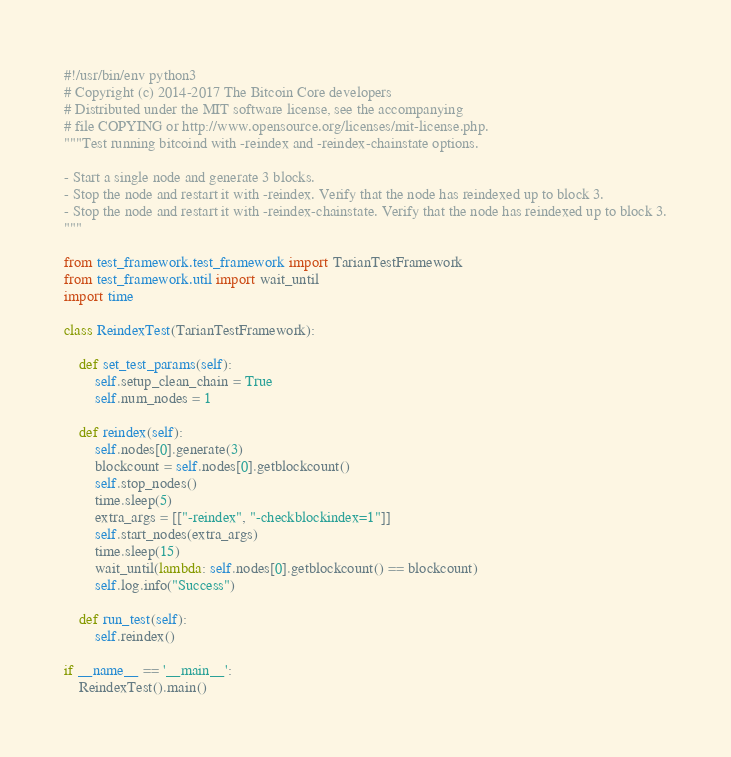Convert code to text. <code><loc_0><loc_0><loc_500><loc_500><_Python_>#!/usr/bin/env python3
# Copyright (c) 2014-2017 The Bitcoin Core developers
# Distributed under the MIT software license, see the accompanying
# file COPYING or http://www.opensource.org/licenses/mit-license.php.
"""Test running bitcoind with -reindex and -reindex-chainstate options.

- Start a single node and generate 3 blocks.
- Stop the node and restart it with -reindex. Verify that the node has reindexed up to block 3.
- Stop the node and restart it with -reindex-chainstate. Verify that the node has reindexed up to block 3.
"""

from test_framework.test_framework import TarianTestFramework
from test_framework.util import wait_until
import time

class ReindexTest(TarianTestFramework):

    def set_test_params(self):
        self.setup_clean_chain = True
        self.num_nodes = 1

    def reindex(self):
        self.nodes[0].generate(3)
        blockcount = self.nodes[0].getblockcount()
        self.stop_nodes()
        time.sleep(5)
        extra_args = [["-reindex", "-checkblockindex=1"]]
        self.start_nodes(extra_args)
        time.sleep(15)
        wait_until(lambda: self.nodes[0].getblockcount() == blockcount)
        self.log.info("Success")

    def run_test(self):
        self.reindex()

if __name__ == '__main__':
    ReindexTest().main()
</code> 